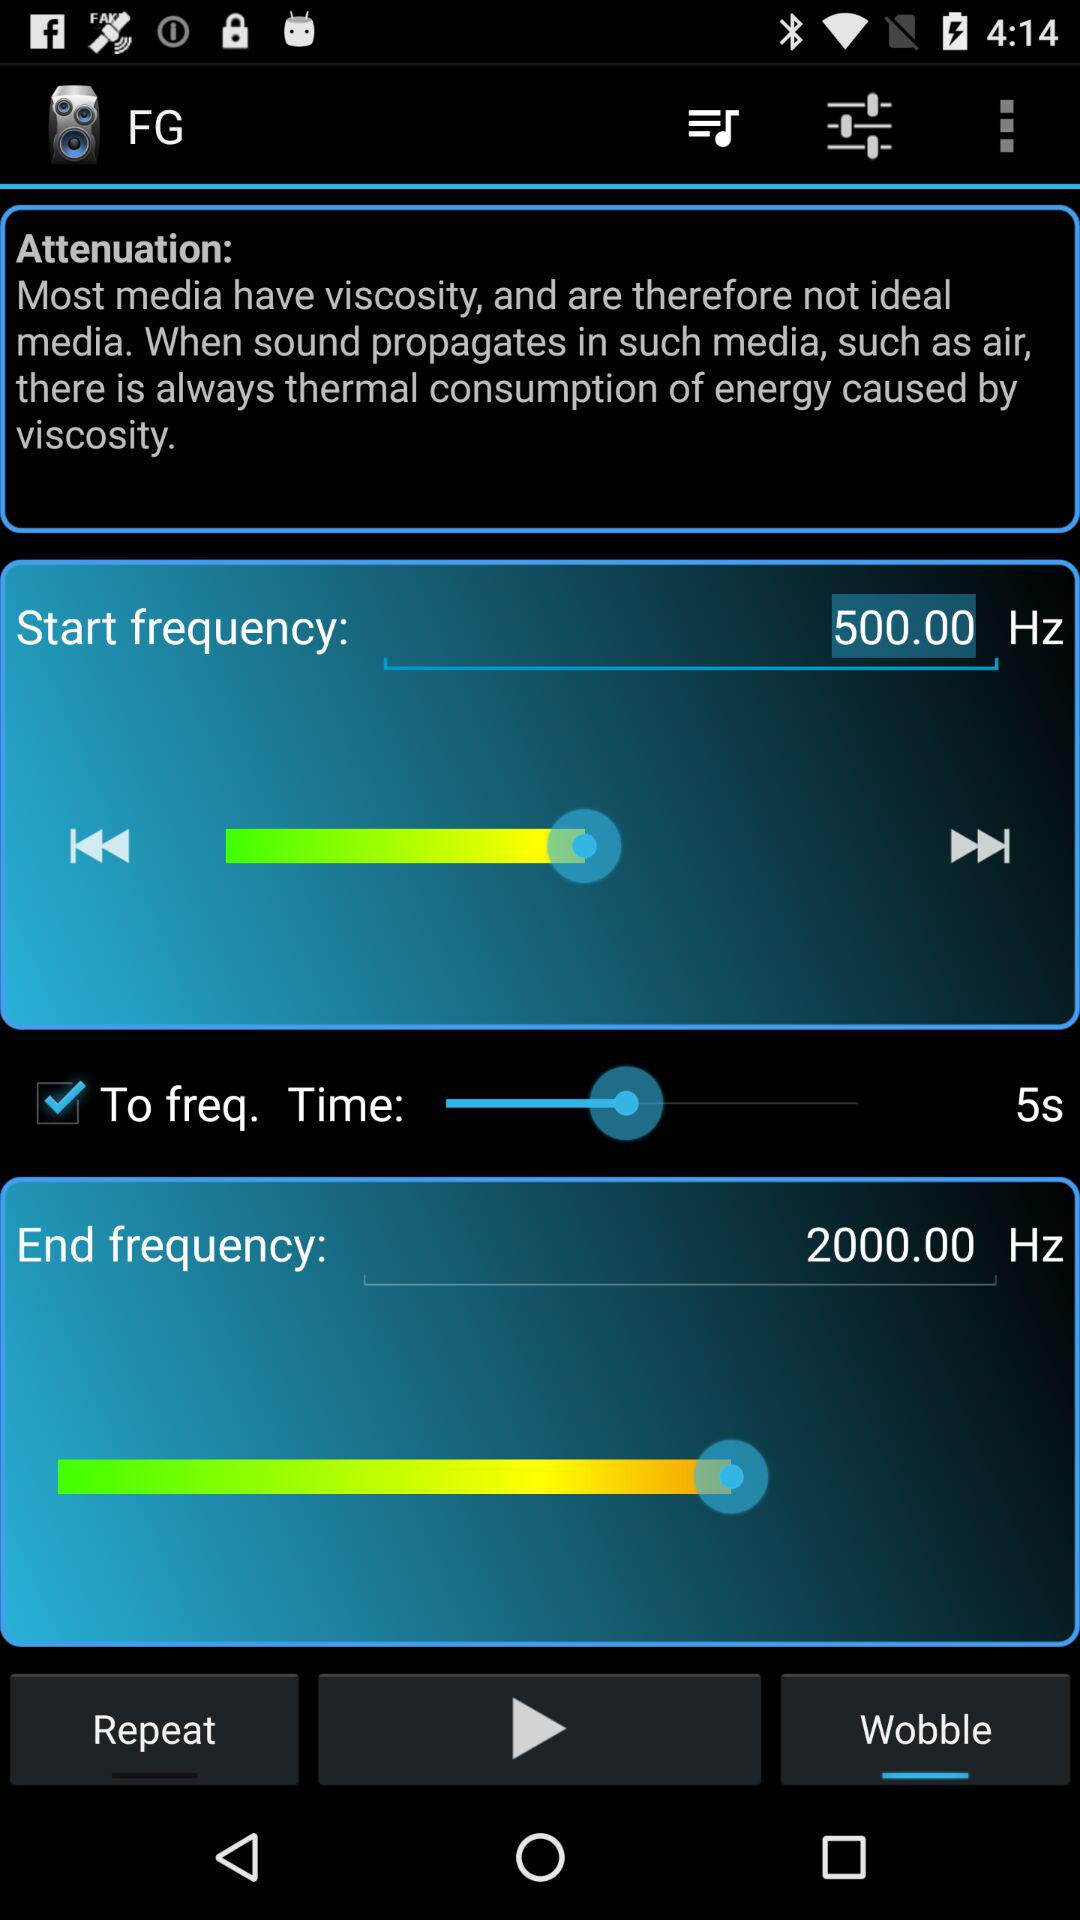How much is the time duration set at? The time duration is set at 5 seconds. 